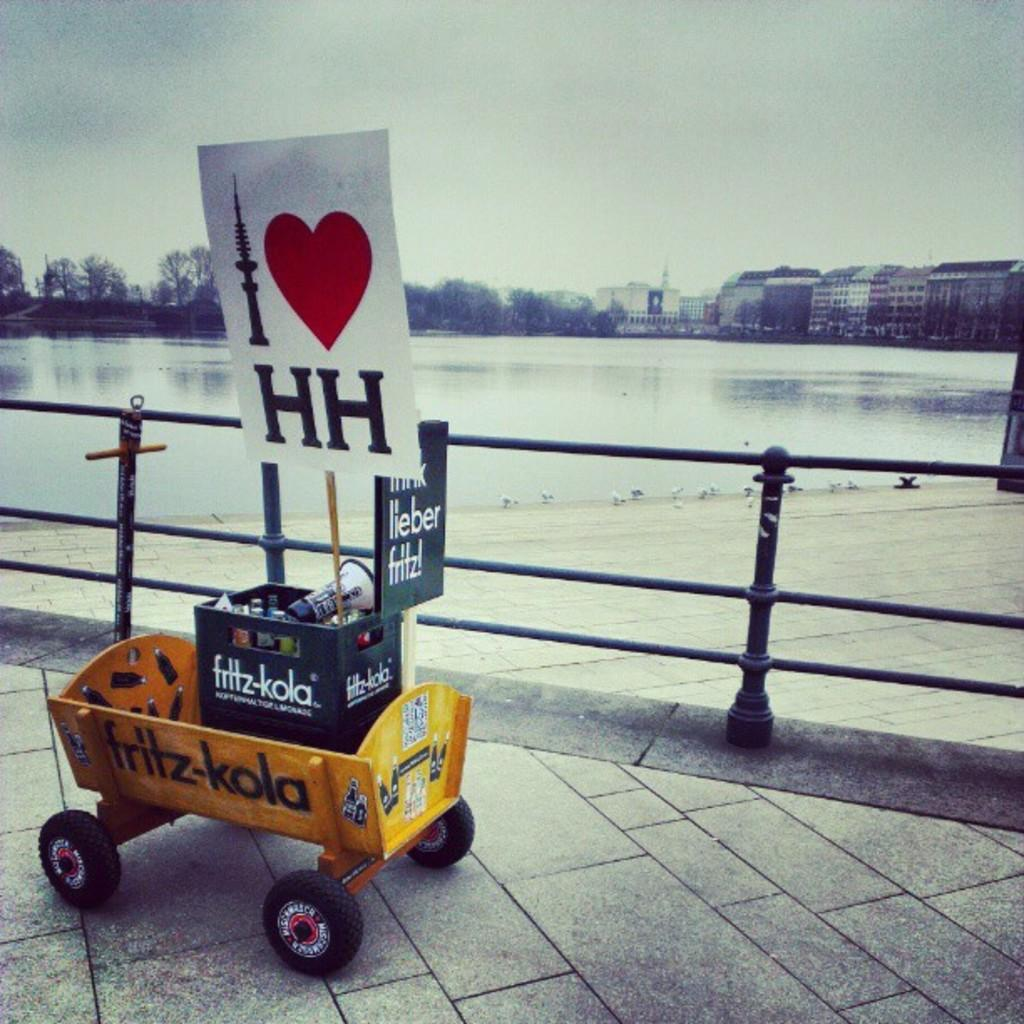What object can be seen in the image that is typically used for cooking? There is a pot in the image that is typically used for cooking. What type of structure is visible in the image that separates areas or provides a boundary? There is a fence in the image that separates areas or provides a boundary. What type of vegetation is visible in the image? There are trees in the image. What type of man-made structures are visible in the image? There are buildings in the image. What type of transportation is visible on the road in the image? There is a vehicle on the road in the image. What type of stamp can be seen on the vehicle in the image? There is no stamp visible on the vehicle in the image. What type of beef dish is being prepared in the pot in the image? There is no beef dish being prepared in the pot in the image; it is just a pot. 